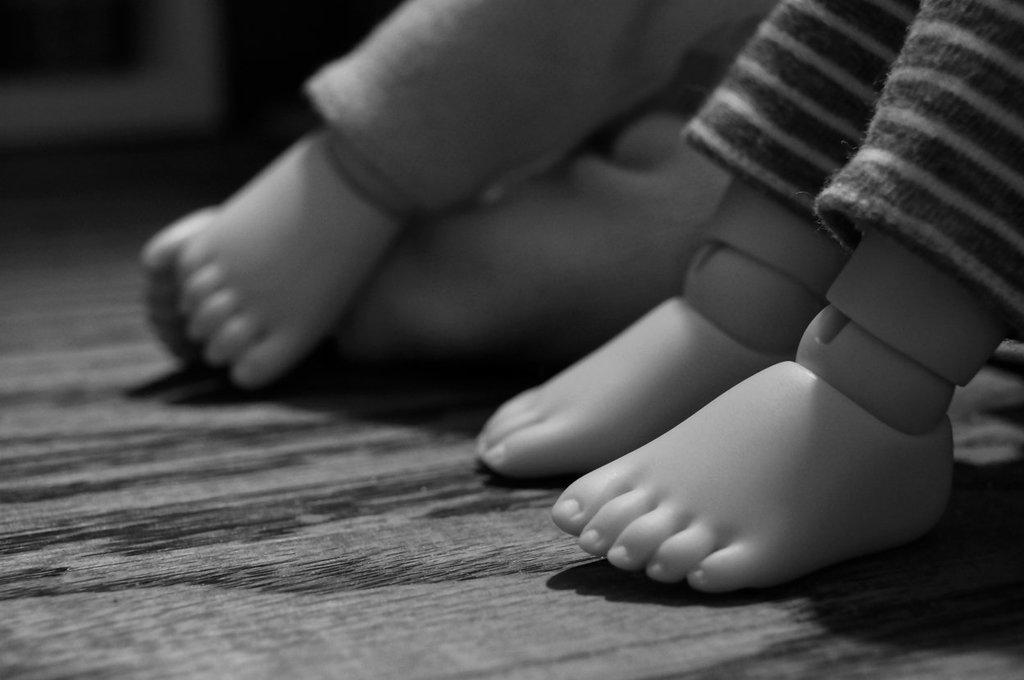What type of objects are featured in the image? The image consists of dolls. What part of the dolls can be seen in the image? Only the legs of the dolls are visible in the image. What is the color scheme of the image? The image is black and white. What type of farming equipment can be seen in the image? There is no farming equipment present in the image; it features only dolls with visible legs in a black and white color scheme. 